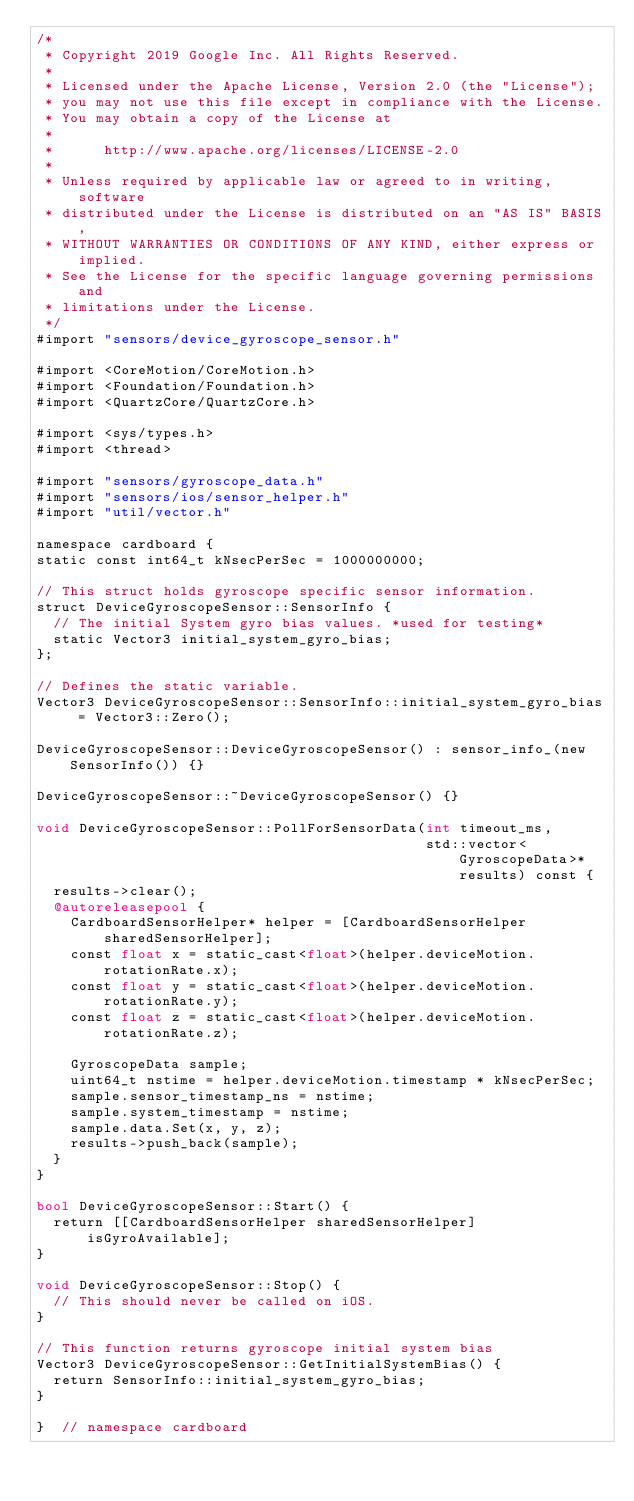Convert code to text. <code><loc_0><loc_0><loc_500><loc_500><_ObjectiveC_>/*
 * Copyright 2019 Google Inc. All Rights Reserved.
 *
 * Licensed under the Apache License, Version 2.0 (the "License");
 * you may not use this file except in compliance with the License.
 * You may obtain a copy of the License at
 *
 *      http://www.apache.org/licenses/LICENSE-2.0
 *
 * Unless required by applicable law or agreed to in writing, software
 * distributed under the License is distributed on an "AS IS" BASIS,
 * WITHOUT WARRANTIES OR CONDITIONS OF ANY KIND, either express or implied.
 * See the License for the specific language governing permissions and
 * limitations under the License.
 */
#import "sensors/device_gyroscope_sensor.h"

#import <CoreMotion/CoreMotion.h>
#import <Foundation/Foundation.h>
#import <QuartzCore/QuartzCore.h>

#import <sys/types.h>
#import <thread>

#import "sensors/gyroscope_data.h"
#import "sensors/ios/sensor_helper.h"
#import "util/vector.h"

namespace cardboard {
static const int64_t kNsecPerSec = 1000000000;

// This struct holds gyroscope specific sensor information.
struct DeviceGyroscopeSensor::SensorInfo {
  // The initial System gyro bias values. *used for testing*
  static Vector3 initial_system_gyro_bias;
};

// Defines the static variable.
Vector3 DeviceGyroscopeSensor::SensorInfo::initial_system_gyro_bias = Vector3::Zero();

DeviceGyroscopeSensor::DeviceGyroscopeSensor() : sensor_info_(new SensorInfo()) {}

DeviceGyroscopeSensor::~DeviceGyroscopeSensor() {}

void DeviceGyroscopeSensor::PollForSensorData(int timeout_ms,
                                              std::vector<GyroscopeData>* results) const {
  results->clear();
  @autoreleasepool {
    CardboardSensorHelper* helper = [CardboardSensorHelper sharedSensorHelper];
    const float x = static_cast<float>(helper.deviceMotion.rotationRate.x);
    const float y = static_cast<float>(helper.deviceMotion.rotationRate.y);
    const float z = static_cast<float>(helper.deviceMotion.rotationRate.z);

    GyroscopeData sample;
    uint64_t nstime = helper.deviceMotion.timestamp * kNsecPerSec;
    sample.sensor_timestamp_ns = nstime;
    sample.system_timestamp = nstime;
    sample.data.Set(x, y, z);
    results->push_back(sample);
  }
}

bool DeviceGyroscopeSensor::Start() {
  return [[CardboardSensorHelper sharedSensorHelper] isGyroAvailable];
}

void DeviceGyroscopeSensor::Stop() {
  // This should never be called on iOS.
}

// This function returns gyroscope initial system bias
Vector3 DeviceGyroscopeSensor::GetInitialSystemBias() {
  return SensorInfo::initial_system_gyro_bias;
}

}  // namespace cardboard
</code> 